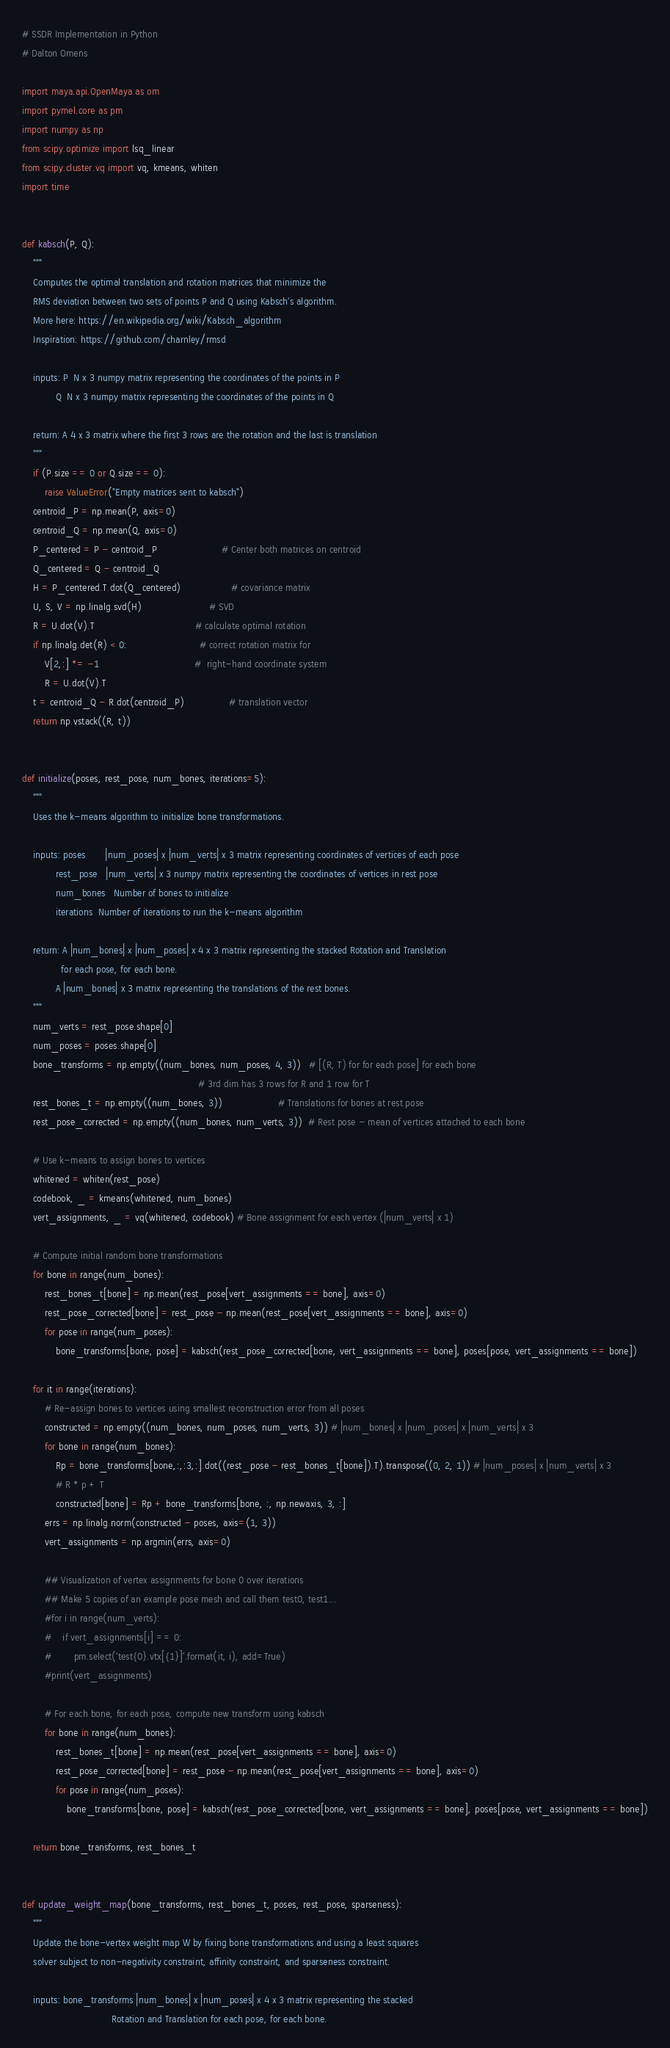<code> <loc_0><loc_0><loc_500><loc_500><_Python_># SSDR Implementation in Python
# Dalton Omens

import maya.api.OpenMaya as om
import pymel.core as pm
import numpy as np
from scipy.optimize import lsq_linear
from scipy.cluster.vq import vq, kmeans, whiten
import time


def kabsch(P, Q):
    """
    Computes the optimal translation and rotation matrices that minimize the 
    RMS deviation between two sets of points P and Q using Kabsch's algorithm.
    More here: https://en.wikipedia.org/wiki/Kabsch_algorithm
    Inspiration: https://github.com/charnley/rmsd
    
    inputs: P  N x 3 numpy matrix representing the coordinates of the points in P
            Q  N x 3 numpy matrix representing the coordinates of the points in Q
            
    return: A 4 x 3 matrix where the first 3 rows are the rotation and the last is translation
    """
    if (P.size == 0 or Q.size == 0):
        raise ValueError("Empty matrices sent to kabsch")
    centroid_P = np.mean(P, axis=0)
    centroid_Q = np.mean(Q, axis=0)
    P_centered = P - centroid_P                       # Center both matrices on centroid
    Q_centered = Q - centroid_Q
    H = P_centered.T.dot(Q_centered)                  # covariance matrix
    U, S, V = np.linalg.svd(H)                        # SVD
    R = U.dot(V).T                                    # calculate optimal rotation
    if np.linalg.det(R) < 0:                          # correct rotation matrix for             
        V[2,:] *= -1                                  #  right-hand coordinate system
        R = U.dot(V).T                          
    t = centroid_Q - R.dot(centroid_P)                # translation vector
    return np.vstack((R, t))


def initialize(poses, rest_pose, num_bones, iterations=5):
    """
    Uses the k-means algorithm to initialize bone transformations.

    inputs: poses       |num_poses| x |num_verts| x 3 matrix representing coordinates of vertices of each pose
            rest_pose   |num_verts| x 3 numpy matrix representing the coordinates of vertices in rest pose
            num_bones   Number of bones to initialize
            iterations  Number of iterations to run the k-means algorithm

    return: A |num_bones| x |num_poses| x 4 x 3 matrix representing the stacked Rotation and Translation
              for each pose, for each bone.
            A |num_bones| x 3 matrix representing the translations of the rest bones.
    """
    num_verts = rest_pose.shape[0]
    num_poses = poses.shape[0]
    bone_transforms = np.empty((num_bones, num_poses, 4, 3))   # [(R, T) for for each pose] for each bone
                                                               # 3rd dim has 3 rows for R and 1 row for T            
    rest_bones_t = np.empty((num_bones, 3))                    # Translations for bones at rest pose
    rest_pose_corrected = np.empty((num_bones, num_verts, 3))  # Rest pose - mean of vertices attached to each bone

    # Use k-means to assign bones to vertices
    whitened = whiten(rest_pose)
    codebook, _ = kmeans(whitened, num_bones)
    vert_assignments, _ = vq(whitened, codebook) # Bone assignment for each vertex (|num_verts| x 1)
    
    # Compute initial random bone transformations
    for bone in range(num_bones):
        rest_bones_t[bone] = np.mean(rest_pose[vert_assignments == bone], axis=0)
        rest_pose_corrected[bone] = rest_pose - np.mean(rest_pose[vert_assignments == bone], axis=0)
        for pose in range(num_poses):
            bone_transforms[bone, pose] = kabsch(rest_pose_corrected[bone, vert_assignments == bone], poses[pose, vert_assignments == bone])
    
    for it in range(iterations):
        # Re-assign bones to vertices using smallest reconstruction error from all poses
        constructed = np.empty((num_bones, num_poses, num_verts, 3)) # |num_bones| x |num_poses| x |num_verts| x 3
        for bone in range(num_bones):
            Rp = bone_transforms[bone,:,:3,:].dot((rest_pose - rest_bones_t[bone]).T).transpose((0, 2, 1)) # |num_poses| x |num_verts| x 3
            # R * p + T
            constructed[bone] = Rp + bone_transforms[bone, :, np.newaxis, 3, :]
        errs = np.linalg.norm(constructed - poses, axis=(1, 3))
        vert_assignments = np.argmin(errs, axis=0)    
        
        ## Visualization of vertex assignments for bone 0 over iterations
        ## Make 5 copies of an example pose mesh and call them test0, test1...
        #for i in range(num_verts):
        #    if vert_assignments[i] == 0:
        #        pm.select('test{0}.vtx[{1}]'.format(it, i), add=True)
        #print(vert_assignments)

        # For each bone, for each pose, compute new transform using kabsch
        for bone in range(num_bones):
            rest_bones_t[bone] = np.mean(rest_pose[vert_assignments == bone], axis=0)
            rest_pose_corrected[bone] = rest_pose - np.mean(rest_pose[vert_assignments == bone], axis=0)
            for pose in range(num_poses):
                bone_transforms[bone, pose] = kabsch(rest_pose_corrected[bone, vert_assignments == bone], poses[pose, vert_assignments == bone])

    return bone_transforms, rest_bones_t


def update_weight_map(bone_transforms, rest_bones_t, poses, rest_pose, sparseness):
    """
    Update the bone-vertex weight map W by fixing bone transformations and using a least squares
    solver subject to non-negativity constraint, affinity constraint, and sparseness constraint.

    inputs: bone_transforms |num_bones| x |num_poses| x 4 x 3 matrix representing the stacked 
                                Rotation and Translation for each pose, for each bone.</code> 